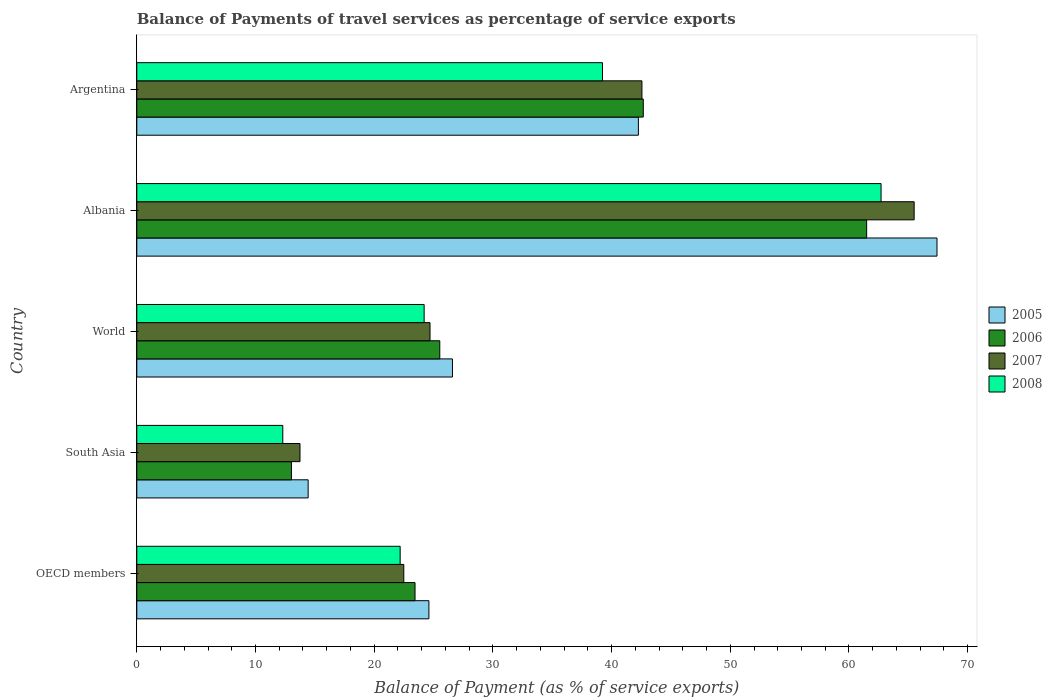How many different coloured bars are there?
Your response must be concise. 4. How many groups of bars are there?
Offer a very short reply. 5. Are the number of bars per tick equal to the number of legend labels?
Offer a very short reply. Yes. Are the number of bars on each tick of the Y-axis equal?
Offer a very short reply. Yes. How many bars are there on the 5th tick from the bottom?
Your answer should be compact. 4. What is the label of the 3rd group of bars from the top?
Offer a terse response. World. In how many cases, is the number of bars for a given country not equal to the number of legend labels?
Offer a very short reply. 0. What is the balance of payments of travel services in 2007 in Argentina?
Give a very brief answer. 42.56. Across all countries, what is the maximum balance of payments of travel services in 2008?
Make the answer very short. 62.7. Across all countries, what is the minimum balance of payments of travel services in 2007?
Ensure brevity in your answer.  13.75. In which country was the balance of payments of travel services in 2005 maximum?
Keep it short and to the point. Albania. In which country was the balance of payments of travel services in 2007 minimum?
Ensure brevity in your answer.  South Asia. What is the total balance of payments of travel services in 2007 in the graph?
Offer a very short reply. 169. What is the difference between the balance of payments of travel services in 2007 in Albania and that in Argentina?
Your answer should be very brief. 22.93. What is the difference between the balance of payments of travel services in 2006 in Argentina and the balance of payments of travel services in 2005 in World?
Ensure brevity in your answer.  16.08. What is the average balance of payments of travel services in 2008 per country?
Your response must be concise. 32.13. What is the difference between the balance of payments of travel services in 2007 and balance of payments of travel services in 2005 in World?
Provide a succinct answer. -1.89. In how many countries, is the balance of payments of travel services in 2008 greater than 56 %?
Your answer should be very brief. 1. What is the ratio of the balance of payments of travel services in 2008 in Albania to that in OECD members?
Provide a short and direct response. 2.83. Is the balance of payments of travel services in 2006 in Argentina less than that in South Asia?
Your answer should be very brief. No. What is the difference between the highest and the second highest balance of payments of travel services in 2008?
Provide a short and direct response. 23.47. What is the difference between the highest and the lowest balance of payments of travel services in 2007?
Keep it short and to the point. 51.74. Is the sum of the balance of payments of travel services in 2006 in OECD members and South Asia greater than the maximum balance of payments of travel services in 2005 across all countries?
Ensure brevity in your answer.  No. How many bars are there?
Your answer should be compact. 20. Are all the bars in the graph horizontal?
Your response must be concise. Yes. Are the values on the major ticks of X-axis written in scientific E-notation?
Offer a terse response. No. What is the title of the graph?
Give a very brief answer. Balance of Payments of travel services as percentage of service exports. Does "2006" appear as one of the legend labels in the graph?
Offer a very short reply. Yes. What is the label or title of the X-axis?
Your response must be concise. Balance of Payment (as % of service exports). What is the label or title of the Y-axis?
Offer a terse response. Country. What is the Balance of Payment (as % of service exports) in 2005 in OECD members?
Your answer should be compact. 24.61. What is the Balance of Payment (as % of service exports) in 2006 in OECD members?
Make the answer very short. 23.44. What is the Balance of Payment (as % of service exports) of 2007 in OECD members?
Keep it short and to the point. 22.5. What is the Balance of Payment (as % of service exports) of 2008 in OECD members?
Offer a terse response. 22.19. What is the Balance of Payment (as % of service exports) in 2005 in South Asia?
Provide a short and direct response. 14.44. What is the Balance of Payment (as % of service exports) in 2006 in South Asia?
Keep it short and to the point. 13.03. What is the Balance of Payment (as % of service exports) in 2007 in South Asia?
Offer a very short reply. 13.75. What is the Balance of Payment (as % of service exports) in 2008 in South Asia?
Your answer should be very brief. 12.3. What is the Balance of Payment (as % of service exports) in 2005 in World?
Offer a very short reply. 26.59. What is the Balance of Payment (as % of service exports) in 2006 in World?
Your response must be concise. 25.53. What is the Balance of Payment (as % of service exports) in 2007 in World?
Make the answer very short. 24.7. What is the Balance of Payment (as % of service exports) of 2008 in World?
Offer a terse response. 24.21. What is the Balance of Payment (as % of service exports) of 2005 in Albania?
Ensure brevity in your answer.  67.42. What is the Balance of Payment (as % of service exports) in 2006 in Albania?
Offer a terse response. 61.49. What is the Balance of Payment (as % of service exports) of 2007 in Albania?
Offer a terse response. 65.49. What is the Balance of Payment (as % of service exports) of 2008 in Albania?
Offer a terse response. 62.7. What is the Balance of Payment (as % of service exports) of 2005 in Argentina?
Offer a very short reply. 42.26. What is the Balance of Payment (as % of service exports) in 2006 in Argentina?
Your answer should be compact. 42.67. What is the Balance of Payment (as % of service exports) of 2007 in Argentina?
Make the answer very short. 42.56. What is the Balance of Payment (as % of service exports) of 2008 in Argentina?
Give a very brief answer. 39.23. Across all countries, what is the maximum Balance of Payment (as % of service exports) of 2005?
Make the answer very short. 67.42. Across all countries, what is the maximum Balance of Payment (as % of service exports) in 2006?
Your answer should be compact. 61.49. Across all countries, what is the maximum Balance of Payment (as % of service exports) of 2007?
Offer a terse response. 65.49. Across all countries, what is the maximum Balance of Payment (as % of service exports) of 2008?
Offer a terse response. 62.7. Across all countries, what is the minimum Balance of Payment (as % of service exports) of 2005?
Keep it short and to the point. 14.44. Across all countries, what is the minimum Balance of Payment (as % of service exports) of 2006?
Make the answer very short. 13.03. Across all countries, what is the minimum Balance of Payment (as % of service exports) in 2007?
Give a very brief answer. 13.75. Across all countries, what is the minimum Balance of Payment (as % of service exports) in 2008?
Offer a very short reply. 12.3. What is the total Balance of Payment (as % of service exports) of 2005 in the graph?
Your answer should be very brief. 175.32. What is the total Balance of Payment (as % of service exports) of 2006 in the graph?
Provide a succinct answer. 166.16. What is the total Balance of Payment (as % of service exports) of 2007 in the graph?
Your answer should be compact. 169. What is the total Balance of Payment (as % of service exports) of 2008 in the graph?
Your answer should be compact. 160.64. What is the difference between the Balance of Payment (as % of service exports) of 2005 in OECD members and that in South Asia?
Keep it short and to the point. 10.17. What is the difference between the Balance of Payment (as % of service exports) in 2006 in OECD members and that in South Asia?
Offer a very short reply. 10.41. What is the difference between the Balance of Payment (as % of service exports) of 2007 in OECD members and that in South Asia?
Offer a very short reply. 8.75. What is the difference between the Balance of Payment (as % of service exports) of 2008 in OECD members and that in South Asia?
Your answer should be compact. 9.89. What is the difference between the Balance of Payment (as % of service exports) of 2005 in OECD members and that in World?
Give a very brief answer. -1.98. What is the difference between the Balance of Payment (as % of service exports) of 2006 in OECD members and that in World?
Offer a very short reply. -2.09. What is the difference between the Balance of Payment (as % of service exports) of 2007 in OECD members and that in World?
Give a very brief answer. -2.21. What is the difference between the Balance of Payment (as % of service exports) of 2008 in OECD members and that in World?
Your answer should be compact. -2.02. What is the difference between the Balance of Payment (as % of service exports) of 2005 in OECD members and that in Albania?
Your response must be concise. -42.8. What is the difference between the Balance of Payment (as % of service exports) of 2006 in OECD members and that in Albania?
Provide a short and direct response. -38.05. What is the difference between the Balance of Payment (as % of service exports) of 2007 in OECD members and that in Albania?
Provide a succinct answer. -43. What is the difference between the Balance of Payment (as % of service exports) of 2008 in OECD members and that in Albania?
Your answer should be very brief. -40.52. What is the difference between the Balance of Payment (as % of service exports) of 2005 in OECD members and that in Argentina?
Provide a succinct answer. -17.65. What is the difference between the Balance of Payment (as % of service exports) in 2006 in OECD members and that in Argentina?
Your answer should be very brief. -19.23. What is the difference between the Balance of Payment (as % of service exports) of 2007 in OECD members and that in Argentina?
Provide a succinct answer. -20.06. What is the difference between the Balance of Payment (as % of service exports) of 2008 in OECD members and that in Argentina?
Provide a short and direct response. -17.05. What is the difference between the Balance of Payment (as % of service exports) of 2005 in South Asia and that in World?
Offer a very short reply. -12.16. What is the difference between the Balance of Payment (as % of service exports) of 2006 in South Asia and that in World?
Your answer should be very brief. -12.5. What is the difference between the Balance of Payment (as % of service exports) of 2007 in South Asia and that in World?
Provide a succinct answer. -10.95. What is the difference between the Balance of Payment (as % of service exports) of 2008 in South Asia and that in World?
Make the answer very short. -11.91. What is the difference between the Balance of Payment (as % of service exports) in 2005 in South Asia and that in Albania?
Provide a succinct answer. -52.98. What is the difference between the Balance of Payment (as % of service exports) in 2006 in South Asia and that in Albania?
Provide a short and direct response. -48.46. What is the difference between the Balance of Payment (as % of service exports) of 2007 in South Asia and that in Albania?
Offer a terse response. -51.74. What is the difference between the Balance of Payment (as % of service exports) of 2008 in South Asia and that in Albania?
Give a very brief answer. -50.4. What is the difference between the Balance of Payment (as % of service exports) of 2005 in South Asia and that in Argentina?
Provide a succinct answer. -27.82. What is the difference between the Balance of Payment (as % of service exports) in 2006 in South Asia and that in Argentina?
Keep it short and to the point. -29.64. What is the difference between the Balance of Payment (as % of service exports) of 2007 in South Asia and that in Argentina?
Provide a short and direct response. -28.81. What is the difference between the Balance of Payment (as % of service exports) of 2008 in South Asia and that in Argentina?
Give a very brief answer. -26.93. What is the difference between the Balance of Payment (as % of service exports) in 2005 in World and that in Albania?
Ensure brevity in your answer.  -40.82. What is the difference between the Balance of Payment (as % of service exports) of 2006 in World and that in Albania?
Your response must be concise. -35.96. What is the difference between the Balance of Payment (as % of service exports) in 2007 in World and that in Albania?
Your answer should be compact. -40.79. What is the difference between the Balance of Payment (as % of service exports) of 2008 in World and that in Albania?
Keep it short and to the point. -38.5. What is the difference between the Balance of Payment (as % of service exports) in 2005 in World and that in Argentina?
Your answer should be compact. -15.66. What is the difference between the Balance of Payment (as % of service exports) in 2006 in World and that in Argentina?
Your answer should be very brief. -17.15. What is the difference between the Balance of Payment (as % of service exports) of 2007 in World and that in Argentina?
Your response must be concise. -17.85. What is the difference between the Balance of Payment (as % of service exports) of 2008 in World and that in Argentina?
Ensure brevity in your answer.  -15.03. What is the difference between the Balance of Payment (as % of service exports) of 2005 in Albania and that in Argentina?
Your response must be concise. 25.16. What is the difference between the Balance of Payment (as % of service exports) in 2006 in Albania and that in Argentina?
Your response must be concise. 18.82. What is the difference between the Balance of Payment (as % of service exports) in 2007 in Albania and that in Argentina?
Provide a short and direct response. 22.93. What is the difference between the Balance of Payment (as % of service exports) of 2008 in Albania and that in Argentina?
Provide a succinct answer. 23.47. What is the difference between the Balance of Payment (as % of service exports) in 2005 in OECD members and the Balance of Payment (as % of service exports) in 2006 in South Asia?
Your answer should be very brief. 11.58. What is the difference between the Balance of Payment (as % of service exports) in 2005 in OECD members and the Balance of Payment (as % of service exports) in 2007 in South Asia?
Provide a succinct answer. 10.86. What is the difference between the Balance of Payment (as % of service exports) of 2005 in OECD members and the Balance of Payment (as % of service exports) of 2008 in South Asia?
Ensure brevity in your answer.  12.31. What is the difference between the Balance of Payment (as % of service exports) in 2006 in OECD members and the Balance of Payment (as % of service exports) in 2007 in South Asia?
Provide a short and direct response. 9.69. What is the difference between the Balance of Payment (as % of service exports) of 2006 in OECD members and the Balance of Payment (as % of service exports) of 2008 in South Asia?
Provide a succinct answer. 11.14. What is the difference between the Balance of Payment (as % of service exports) in 2007 in OECD members and the Balance of Payment (as % of service exports) in 2008 in South Asia?
Your answer should be compact. 10.19. What is the difference between the Balance of Payment (as % of service exports) of 2005 in OECD members and the Balance of Payment (as % of service exports) of 2006 in World?
Keep it short and to the point. -0.92. What is the difference between the Balance of Payment (as % of service exports) in 2005 in OECD members and the Balance of Payment (as % of service exports) in 2007 in World?
Your answer should be compact. -0.09. What is the difference between the Balance of Payment (as % of service exports) in 2005 in OECD members and the Balance of Payment (as % of service exports) in 2008 in World?
Give a very brief answer. 0.4. What is the difference between the Balance of Payment (as % of service exports) in 2006 in OECD members and the Balance of Payment (as % of service exports) in 2007 in World?
Provide a succinct answer. -1.26. What is the difference between the Balance of Payment (as % of service exports) of 2006 in OECD members and the Balance of Payment (as % of service exports) of 2008 in World?
Your answer should be very brief. -0.77. What is the difference between the Balance of Payment (as % of service exports) in 2007 in OECD members and the Balance of Payment (as % of service exports) in 2008 in World?
Your answer should be very brief. -1.71. What is the difference between the Balance of Payment (as % of service exports) of 2005 in OECD members and the Balance of Payment (as % of service exports) of 2006 in Albania?
Offer a terse response. -36.88. What is the difference between the Balance of Payment (as % of service exports) in 2005 in OECD members and the Balance of Payment (as % of service exports) in 2007 in Albania?
Your response must be concise. -40.88. What is the difference between the Balance of Payment (as % of service exports) in 2005 in OECD members and the Balance of Payment (as % of service exports) in 2008 in Albania?
Ensure brevity in your answer.  -38.09. What is the difference between the Balance of Payment (as % of service exports) of 2006 in OECD members and the Balance of Payment (as % of service exports) of 2007 in Albania?
Provide a succinct answer. -42.05. What is the difference between the Balance of Payment (as % of service exports) of 2006 in OECD members and the Balance of Payment (as % of service exports) of 2008 in Albania?
Provide a succinct answer. -39.26. What is the difference between the Balance of Payment (as % of service exports) of 2007 in OECD members and the Balance of Payment (as % of service exports) of 2008 in Albania?
Give a very brief answer. -40.21. What is the difference between the Balance of Payment (as % of service exports) in 2005 in OECD members and the Balance of Payment (as % of service exports) in 2006 in Argentina?
Provide a short and direct response. -18.06. What is the difference between the Balance of Payment (as % of service exports) in 2005 in OECD members and the Balance of Payment (as % of service exports) in 2007 in Argentina?
Your answer should be compact. -17.95. What is the difference between the Balance of Payment (as % of service exports) in 2005 in OECD members and the Balance of Payment (as % of service exports) in 2008 in Argentina?
Give a very brief answer. -14.62. What is the difference between the Balance of Payment (as % of service exports) of 2006 in OECD members and the Balance of Payment (as % of service exports) of 2007 in Argentina?
Offer a very short reply. -19.12. What is the difference between the Balance of Payment (as % of service exports) in 2006 in OECD members and the Balance of Payment (as % of service exports) in 2008 in Argentina?
Provide a succinct answer. -15.79. What is the difference between the Balance of Payment (as % of service exports) in 2007 in OECD members and the Balance of Payment (as % of service exports) in 2008 in Argentina?
Your answer should be compact. -16.74. What is the difference between the Balance of Payment (as % of service exports) of 2005 in South Asia and the Balance of Payment (as % of service exports) of 2006 in World?
Provide a short and direct response. -11.09. What is the difference between the Balance of Payment (as % of service exports) of 2005 in South Asia and the Balance of Payment (as % of service exports) of 2007 in World?
Ensure brevity in your answer.  -10.27. What is the difference between the Balance of Payment (as % of service exports) of 2005 in South Asia and the Balance of Payment (as % of service exports) of 2008 in World?
Give a very brief answer. -9.77. What is the difference between the Balance of Payment (as % of service exports) in 2006 in South Asia and the Balance of Payment (as % of service exports) in 2007 in World?
Offer a terse response. -11.68. What is the difference between the Balance of Payment (as % of service exports) in 2006 in South Asia and the Balance of Payment (as % of service exports) in 2008 in World?
Make the answer very short. -11.18. What is the difference between the Balance of Payment (as % of service exports) in 2007 in South Asia and the Balance of Payment (as % of service exports) in 2008 in World?
Provide a succinct answer. -10.46. What is the difference between the Balance of Payment (as % of service exports) in 2005 in South Asia and the Balance of Payment (as % of service exports) in 2006 in Albania?
Offer a very short reply. -47.05. What is the difference between the Balance of Payment (as % of service exports) of 2005 in South Asia and the Balance of Payment (as % of service exports) of 2007 in Albania?
Your answer should be very brief. -51.05. What is the difference between the Balance of Payment (as % of service exports) in 2005 in South Asia and the Balance of Payment (as % of service exports) in 2008 in Albania?
Offer a terse response. -48.27. What is the difference between the Balance of Payment (as % of service exports) of 2006 in South Asia and the Balance of Payment (as % of service exports) of 2007 in Albania?
Provide a short and direct response. -52.47. What is the difference between the Balance of Payment (as % of service exports) of 2006 in South Asia and the Balance of Payment (as % of service exports) of 2008 in Albania?
Offer a terse response. -49.68. What is the difference between the Balance of Payment (as % of service exports) of 2007 in South Asia and the Balance of Payment (as % of service exports) of 2008 in Albania?
Provide a short and direct response. -48.95. What is the difference between the Balance of Payment (as % of service exports) of 2005 in South Asia and the Balance of Payment (as % of service exports) of 2006 in Argentina?
Make the answer very short. -28.23. What is the difference between the Balance of Payment (as % of service exports) of 2005 in South Asia and the Balance of Payment (as % of service exports) of 2007 in Argentina?
Offer a very short reply. -28.12. What is the difference between the Balance of Payment (as % of service exports) of 2005 in South Asia and the Balance of Payment (as % of service exports) of 2008 in Argentina?
Offer a very short reply. -24.8. What is the difference between the Balance of Payment (as % of service exports) in 2006 in South Asia and the Balance of Payment (as % of service exports) in 2007 in Argentina?
Provide a succinct answer. -29.53. What is the difference between the Balance of Payment (as % of service exports) in 2006 in South Asia and the Balance of Payment (as % of service exports) in 2008 in Argentina?
Offer a very short reply. -26.21. What is the difference between the Balance of Payment (as % of service exports) of 2007 in South Asia and the Balance of Payment (as % of service exports) of 2008 in Argentina?
Offer a very short reply. -25.48. What is the difference between the Balance of Payment (as % of service exports) in 2005 in World and the Balance of Payment (as % of service exports) in 2006 in Albania?
Your answer should be compact. -34.9. What is the difference between the Balance of Payment (as % of service exports) of 2005 in World and the Balance of Payment (as % of service exports) of 2007 in Albania?
Make the answer very short. -38.9. What is the difference between the Balance of Payment (as % of service exports) in 2005 in World and the Balance of Payment (as % of service exports) in 2008 in Albania?
Keep it short and to the point. -36.11. What is the difference between the Balance of Payment (as % of service exports) of 2006 in World and the Balance of Payment (as % of service exports) of 2007 in Albania?
Offer a terse response. -39.97. What is the difference between the Balance of Payment (as % of service exports) in 2006 in World and the Balance of Payment (as % of service exports) in 2008 in Albania?
Your response must be concise. -37.18. What is the difference between the Balance of Payment (as % of service exports) in 2007 in World and the Balance of Payment (as % of service exports) in 2008 in Albania?
Ensure brevity in your answer.  -38. What is the difference between the Balance of Payment (as % of service exports) in 2005 in World and the Balance of Payment (as % of service exports) in 2006 in Argentina?
Your answer should be very brief. -16.08. What is the difference between the Balance of Payment (as % of service exports) in 2005 in World and the Balance of Payment (as % of service exports) in 2007 in Argentina?
Provide a succinct answer. -15.96. What is the difference between the Balance of Payment (as % of service exports) of 2005 in World and the Balance of Payment (as % of service exports) of 2008 in Argentina?
Your answer should be very brief. -12.64. What is the difference between the Balance of Payment (as % of service exports) of 2006 in World and the Balance of Payment (as % of service exports) of 2007 in Argentina?
Offer a terse response. -17.03. What is the difference between the Balance of Payment (as % of service exports) in 2006 in World and the Balance of Payment (as % of service exports) in 2008 in Argentina?
Provide a short and direct response. -13.71. What is the difference between the Balance of Payment (as % of service exports) of 2007 in World and the Balance of Payment (as % of service exports) of 2008 in Argentina?
Your answer should be very brief. -14.53. What is the difference between the Balance of Payment (as % of service exports) of 2005 in Albania and the Balance of Payment (as % of service exports) of 2006 in Argentina?
Offer a very short reply. 24.74. What is the difference between the Balance of Payment (as % of service exports) of 2005 in Albania and the Balance of Payment (as % of service exports) of 2007 in Argentina?
Offer a terse response. 24.86. What is the difference between the Balance of Payment (as % of service exports) in 2005 in Albania and the Balance of Payment (as % of service exports) in 2008 in Argentina?
Your response must be concise. 28.18. What is the difference between the Balance of Payment (as % of service exports) of 2006 in Albania and the Balance of Payment (as % of service exports) of 2007 in Argentina?
Make the answer very short. 18.93. What is the difference between the Balance of Payment (as % of service exports) of 2006 in Albania and the Balance of Payment (as % of service exports) of 2008 in Argentina?
Make the answer very short. 22.26. What is the difference between the Balance of Payment (as % of service exports) of 2007 in Albania and the Balance of Payment (as % of service exports) of 2008 in Argentina?
Ensure brevity in your answer.  26.26. What is the average Balance of Payment (as % of service exports) in 2005 per country?
Your answer should be very brief. 35.06. What is the average Balance of Payment (as % of service exports) in 2006 per country?
Keep it short and to the point. 33.23. What is the average Balance of Payment (as % of service exports) in 2007 per country?
Make the answer very short. 33.8. What is the average Balance of Payment (as % of service exports) in 2008 per country?
Provide a short and direct response. 32.13. What is the difference between the Balance of Payment (as % of service exports) in 2005 and Balance of Payment (as % of service exports) in 2006 in OECD members?
Keep it short and to the point. 1.17. What is the difference between the Balance of Payment (as % of service exports) of 2005 and Balance of Payment (as % of service exports) of 2007 in OECD members?
Keep it short and to the point. 2.12. What is the difference between the Balance of Payment (as % of service exports) in 2005 and Balance of Payment (as % of service exports) in 2008 in OECD members?
Give a very brief answer. 2.42. What is the difference between the Balance of Payment (as % of service exports) in 2006 and Balance of Payment (as % of service exports) in 2007 in OECD members?
Ensure brevity in your answer.  0.95. What is the difference between the Balance of Payment (as % of service exports) in 2006 and Balance of Payment (as % of service exports) in 2008 in OECD members?
Make the answer very short. 1.25. What is the difference between the Balance of Payment (as % of service exports) of 2007 and Balance of Payment (as % of service exports) of 2008 in OECD members?
Offer a very short reply. 0.31. What is the difference between the Balance of Payment (as % of service exports) of 2005 and Balance of Payment (as % of service exports) of 2006 in South Asia?
Your answer should be compact. 1.41. What is the difference between the Balance of Payment (as % of service exports) in 2005 and Balance of Payment (as % of service exports) in 2007 in South Asia?
Ensure brevity in your answer.  0.69. What is the difference between the Balance of Payment (as % of service exports) of 2005 and Balance of Payment (as % of service exports) of 2008 in South Asia?
Keep it short and to the point. 2.14. What is the difference between the Balance of Payment (as % of service exports) of 2006 and Balance of Payment (as % of service exports) of 2007 in South Asia?
Make the answer very short. -0.72. What is the difference between the Balance of Payment (as % of service exports) in 2006 and Balance of Payment (as % of service exports) in 2008 in South Asia?
Your response must be concise. 0.73. What is the difference between the Balance of Payment (as % of service exports) in 2007 and Balance of Payment (as % of service exports) in 2008 in South Asia?
Give a very brief answer. 1.45. What is the difference between the Balance of Payment (as % of service exports) in 2005 and Balance of Payment (as % of service exports) in 2006 in World?
Your answer should be compact. 1.07. What is the difference between the Balance of Payment (as % of service exports) in 2005 and Balance of Payment (as % of service exports) in 2007 in World?
Your response must be concise. 1.89. What is the difference between the Balance of Payment (as % of service exports) in 2005 and Balance of Payment (as % of service exports) in 2008 in World?
Your answer should be very brief. 2.39. What is the difference between the Balance of Payment (as % of service exports) of 2006 and Balance of Payment (as % of service exports) of 2007 in World?
Your answer should be very brief. 0.82. What is the difference between the Balance of Payment (as % of service exports) in 2006 and Balance of Payment (as % of service exports) in 2008 in World?
Give a very brief answer. 1.32. What is the difference between the Balance of Payment (as % of service exports) in 2007 and Balance of Payment (as % of service exports) in 2008 in World?
Your response must be concise. 0.5. What is the difference between the Balance of Payment (as % of service exports) of 2005 and Balance of Payment (as % of service exports) of 2006 in Albania?
Keep it short and to the point. 5.92. What is the difference between the Balance of Payment (as % of service exports) of 2005 and Balance of Payment (as % of service exports) of 2007 in Albania?
Your response must be concise. 1.92. What is the difference between the Balance of Payment (as % of service exports) of 2005 and Balance of Payment (as % of service exports) of 2008 in Albania?
Your answer should be compact. 4.71. What is the difference between the Balance of Payment (as % of service exports) in 2006 and Balance of Payment (as % of service exports) in 2007 in Albania?
Your answer should be very brief. -4. What is the difference between the Balance of Payment (as % of service exports) in 2006 and Balance of Payment (as % of service exports) in 2008 in Albania?
Provide a succinct answer. -1.21. What is the difference between the Balance of Payment (as % of service exports) of 2007 and Balance of Payment (as % of service exports) of 2008 in Albania?
Provide a succinct answer. 2.79. What is the difference between the Balance of Payment (as % of service exports) of 2005 and Balance of Payment (as % of service exports) of 2006 in Argentina?
Make the answer very short. -0.41. What is the difference between the Balance of Payment (as % of service exports) of 2005 and Balance of Payment (as % of service exports) of 2007 in Argentina?
Provide a succinct answer. -0.3. What is the difference between the Balance of Payment (as % of service exports) in 2005 and Balance of Payment (as % of service exports) in 2008 in Argentina?
Your answer should be compact. 3.02. What is the difference between the Balance of Payment (as % of service exports) in 2006 and Balance of Payment (as % of service exports) in 2007 in Argentina?
Provide a succinct answer. 0.11. What is the difference between the Balance of Payment (as % of service exports) in 2006 and Balance of Payment (as % of service exports) in 2008 in Argentina?
Make the answer very short. 3.44. What is the difference between the Balance of Payment (as % of service exports) in 2007 and Balance of Payment (as % of service exports) in 2008 in Argentina?
Offer a very short reply. 3.32. What is the ratio of the Balance of Payment (as % of service exports) of 2005 in OECD members to that in South Asia?
Offer a terse response. 1.7. What is the ratio of the Balance of Payment (as % of service exports) in 2006 in OECD members to that in South Asia?
Provide a short and direct response. 1.8. What is the ratio of the Balance of Payment (as % of service exports) of 2007 in OECD members to that in South Asia?
Your answer should be compact. 1.64. What is the ratio of the Balance of Payment (as % of service exports) of 2008 in OECD members to that in South Asia?
Make the answer very short. 1.8. What is the ratio of the Balance of Payment (as % of service exports) in 2005 in OECD members to that in World?
Your answer should be compact. 0.93. What is the ratio of the Balance of Payment (as % of service exports) of 2006 in OECD members to that in World?
Provide a succinct answer. 0.92. What is the ratio of the Balance of Payment (as % of service exports) of 2007 in OECD members to that in World?
Keep it short and to the point. 0.91. What is the ratio of the Balance of Payment (as % of service exports) of 2008 in OECD members to that in World?
Ensure brevity in your answer.  0.92. What is the ratio of the Balance of Payment (as % of service exports) of 2005 in OECD members to that in Albania?
Offer a terse response. 0.37. What is the ratio of the Balance of Payment (as % of service exports) of 2006 in OECD members to that in Albania?
Provide a succinct answer. 0.38. What is the ratio of the Balance of Payment (as % of service exports) of 2007 in OECD members to that in Albania?
Provide a succinct answer. 0.34. What is the ratio of the Balance of Payment (as % of service exports) of 2008 in OECD members to that in Albania?
Ensure brevity in your answer.  0.35. What is the ratio of the Balance of Payment (as % of service exports) in 2005 in OECD members to that in Argentina?
Make the answer very short. 0.58. What is the ratio of the Balance of Payment (as % of service exports) in 2006 in OECD members to that in Argentina?
Offer a terse response. 0.55. What is the ratio of the Balance of Payment (as % of service exports) in 2007 in OECD members to that in Argentina?
Make the answer very short. 0.53. What is the ratio of the Balance of Payment (as % of service exports) in 2008 in OECD members to that in Argentina?
Make the answer very short. 0.57. What is the ratio of the Balance of Payment (as % of service exports) in 2005 in South Asia to that in World?
Make the answer very short. 0.54. What is the ratio of the Balance of Payment (as % of service exports) in 2006 in South Asia to that in World?
Give a very brief answer. 0.51. What is the ratio of the Balance of Payment (as % of service exports) in 2007 in South Asia to that in World?
Offer a very short reply. 0.56. What is the ratio of the Balance of Payment (as % of service exports) in 2008 in South Asia to that in World?
Provide a short and direct response. 0.51. What is the ratio of the Balance of Payment (as % of service exports) in 2005 in South Asia to that in Albania?
Offer a very short reply. 0.21. What is the ratio of the Balance of Payment (as % of service exports) of 2006 in South Asia to that in Albania?
Your answer should be compact. 0.21. What is the ratio of the Balance of Payment (as % of service exports) in 2007 in South Asia to that in Albania?
Your answer should be compact. 0.21. What is the ratio of the Balance of Payment (as % of service exports) of 2008 in South Asia to that in Albania?
Your answer should be compact. 0.2. What is the ratio of the Balance of Payment (as % of service exports) in 2005 in South Asia to that in Argentina?
Offer a very short reply. 0.34. What is the ratio of the Balance of Payment (as % of service exports) of 2006 in South Asia to that in Argentina?
Keep it short and to the point. 0.31. What is the ratio of the Balance of Payment (as % of service exports) of 2007 in South Asia to that in Argentina?
Your answer should be compact. 0.32. What is the ratio of the Balance of Payment (as % of service exports) of 2008 in South Asia to that in Argentina?
Your answer should be very brief. 0.31. What is the ratio of the Balance of Payment (as % of service exports) in 2005 in World to that in Albania?
Your answer should be very brief. 0.39. What is the ratio of the Balance of Payment (as % of service exports) in 2006 in World to that in Albania?
Provide a short and direct response. 0.42. What is the ratio of the Balance of Payment (as % of service exports) in 2007 in World to that in Albania?
Offer a very short reply. 0.38. What is the ratio of the Balance of Payment (as % of service exports) in 2008 in World to that in Albania?
Your response must be concise. 0.39. What is the ratio of the Balance of Payment (as % of service exports) of 2005 in World to that in Argentina?
Provide a succinct answer. 0.63. What is the ratio of the Balance of Payment (as % of service exports) of 2006 in World to that in Argentina?
Offer a very short reply. 0.6. What is the ratio of the Balance of Payment (as % of service exports) of 2007 in World to that in Argentina?
Give a very brief answer. 0.58. What is the ratio of the Balance of Payment (as % of service exports) in 2008 in World to that in Argentina?
Make the answer very short. 0.62. What is the ratio of the Balance of Payment (as % of service exports) in 2005 in Albania to that in Argentina?
Your answer should be compact. 1.6. What is the ratio of the Balance of Payment (as % of service exports) of 2006 in Albania to that in Argentina?
Ensure brevity in your answer.  1.44. What is the ratio of the Balance of Payment (as % of service exports) of 2007 in Albania to that in Argentina?
Ensure brevity in your answer.  1.54. What is the ratio of the Balance of Payment (as % of service exports) in 2008 in Albania to that in Argentina?
Your response must be concise. 1.6. What is the difference between the highest and the second highest Balance of Payment (as % of service exports) of 2005?
Your answer should be compact. 25.16. What is the difference between the highest and the second highest Balance of Payment (as % of service exports) in 2006?
Make the answer very short. 18.82. What is the difference between the highest and the second highest Balance of Payment (as % of service exports) in 2007?
Your answer should be very brief. 22.93. What is the difference between the highest and the second highest Balance of Payment (as % of service exports) of 2008?
Your response must be concise. 23.47. What is the difference between the highest and the lowest Balance of Payment (as % of service exports) in 2005?
Offer a terse response. 52.98. What is the difference between the highest and the lowest Balance of Payment (as % of service exports) in 2006?
Offer a terse response. 48.46. What is the difference between the highest and the lowest Balance of Payment (as % of service exports) of 2007?
Your answer should be very brief. 51.74. What is the difference between the highest and the lowest Balance of Payment (as % of service exports) of 2008?
Make the answer very short. 50.4. 